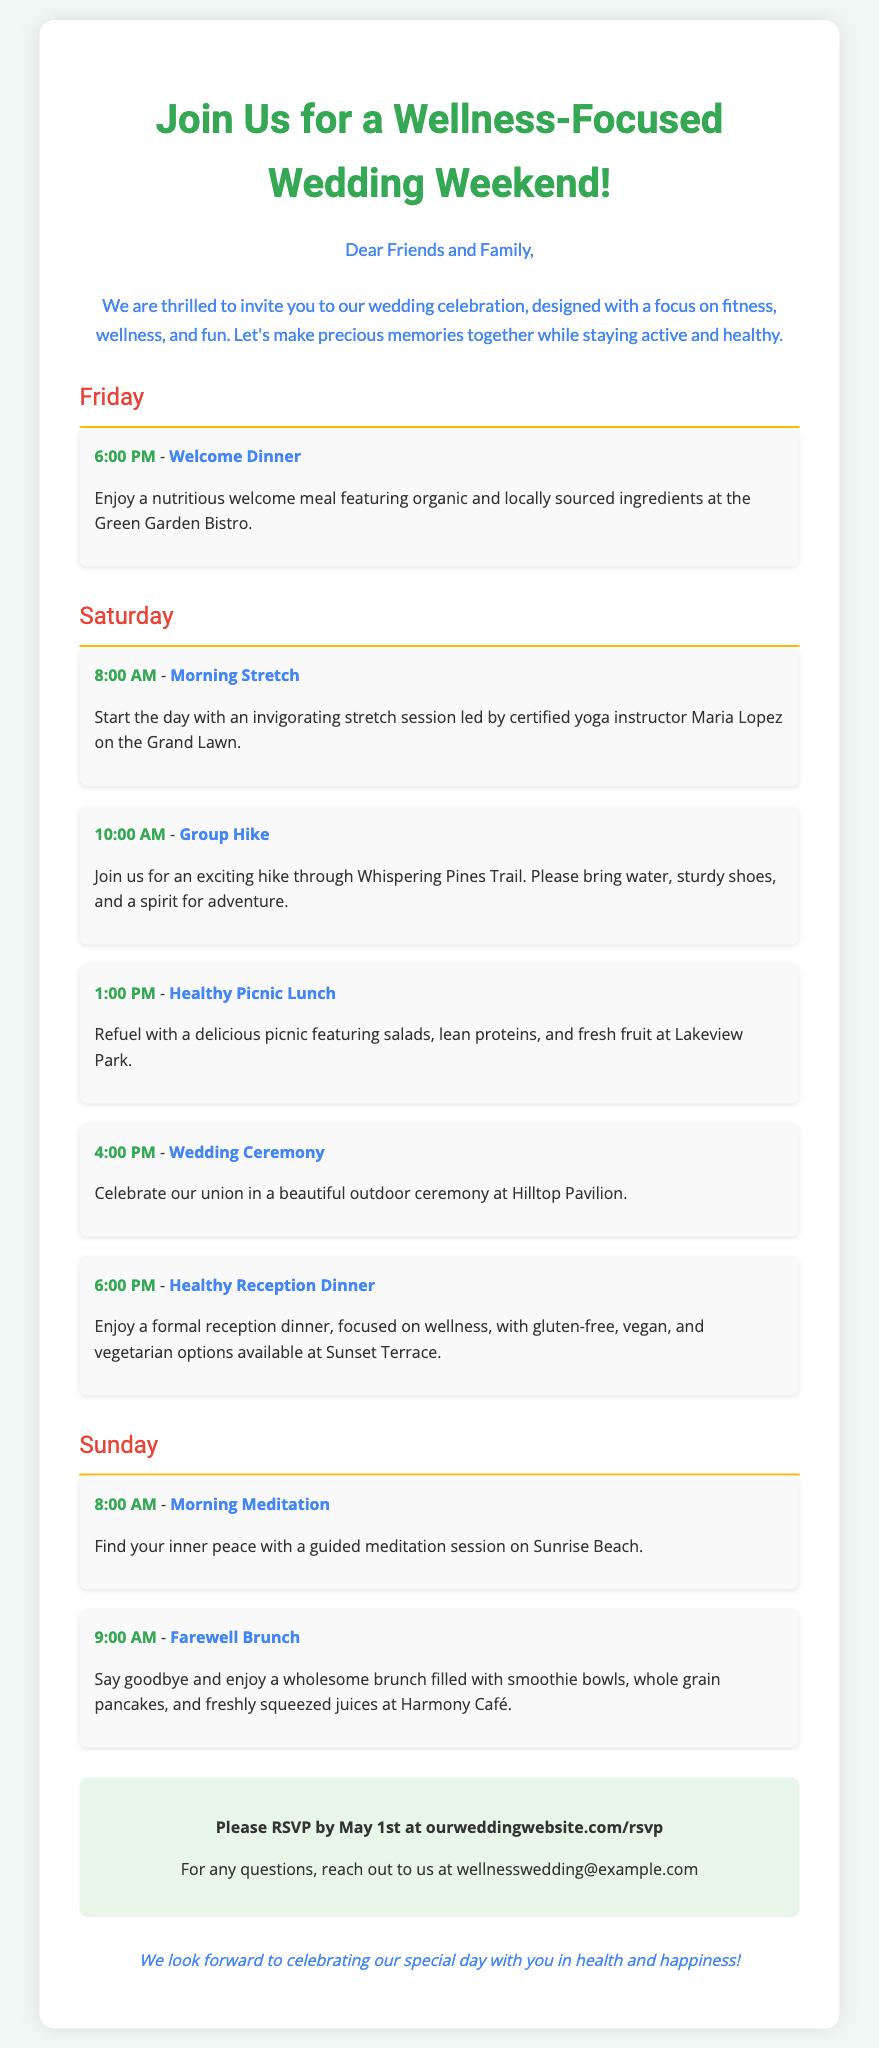What is the date to RSVP? The RSVP deadline is mentioned explicitly in the invitation as May 1st.
Answer: May 1st Who is leading the morning stretch session? The document specifies that a certified yoga instructor named Maria Lopez will lead the morning stretch session.
Answer: Maria Lopez What type of food will be served at the farewell brunch? The farewell brunch includes smoothie bowls, whole grain pancakes, and freshly squeezed juices as described in the document.
Answer: Smoothie bowls, whole grain pancakes, and freshly squeezed juices What time does the wedding ceremony start? The time given for the wedding ceremony in the itinerary is indicated as 4:00 PM.
Answer: 4:00 PM What is the location of the welcome dinner? The welcome dinner is set to take place at the Green Garden Bistro according to the invitation.
Answer: Green Garden Bistro How many main activities are scheduled for Saturday? A total of five activities are planned for Saturday as per the weekend itinerary listed in the document.
Answer: Five What is the theme of the wedding weekend? The invitation highlights a focus on fitness, wellness, and fun as the central theme of the wedding weekend.
Answer: Wellness-focused Where will the afternoon reception dinner be held? The healthy reception dinner is specifically mentioned to take place at Sunset Terrace.
Answer: Sunset Terrace What should guests bring for the group hike? Guests are advised to bring water, sturdy shoes, and a spirit for adventure for the group hike.
Answer: Water, sturdy shoes, and a spirit for adventure 